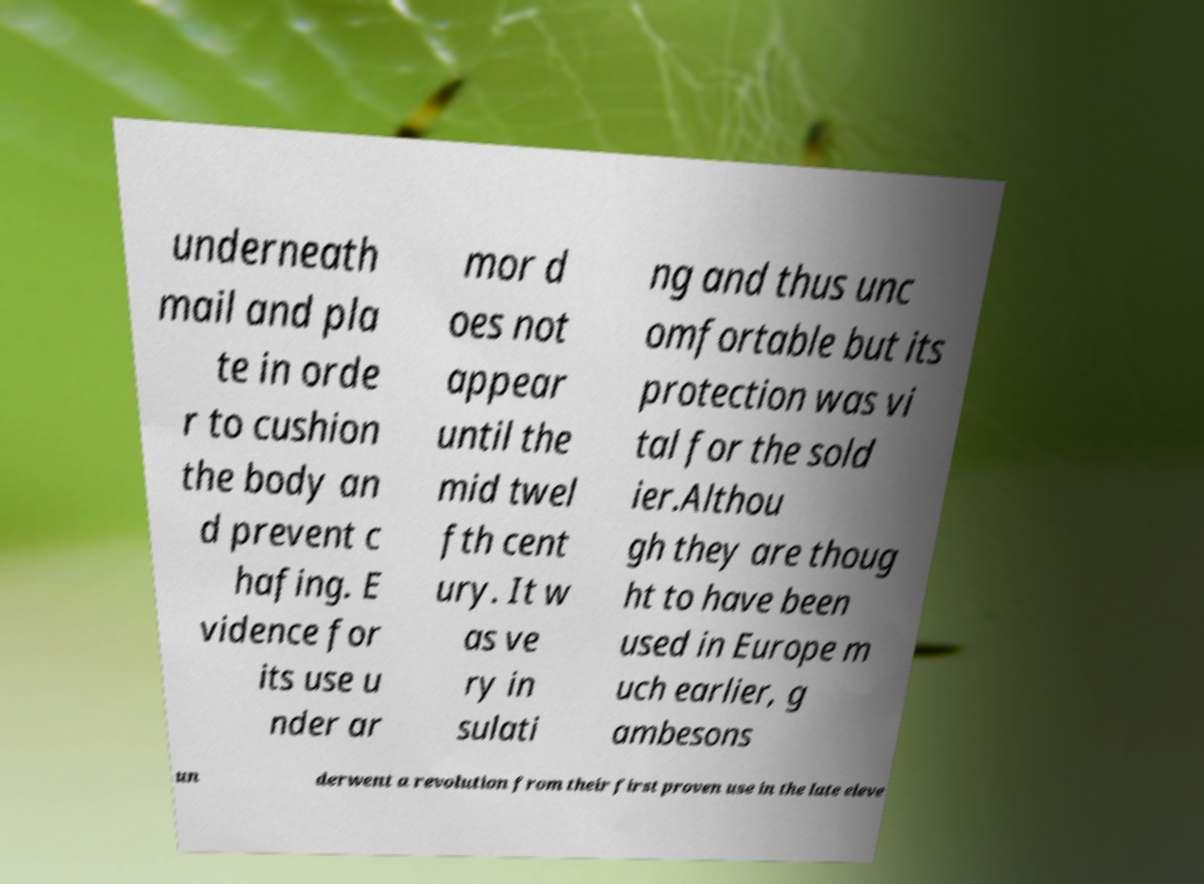I need the written content from this picture converted into text. Can you do that? underneath mail and pla te in orde r to cushion the body an d prevent c hafing. E vidence for its use u nder ar mor d oes not appear until the mid twel fth cent ury. It w as ve ry in sulati ng and thus unc omfortable but its protection was vi tal for the sold ier.Althou gh they are thoug ht to have been used in Europe m uch earlier, g ambesons un derwent a revolution from their first proven use in the late eleve 